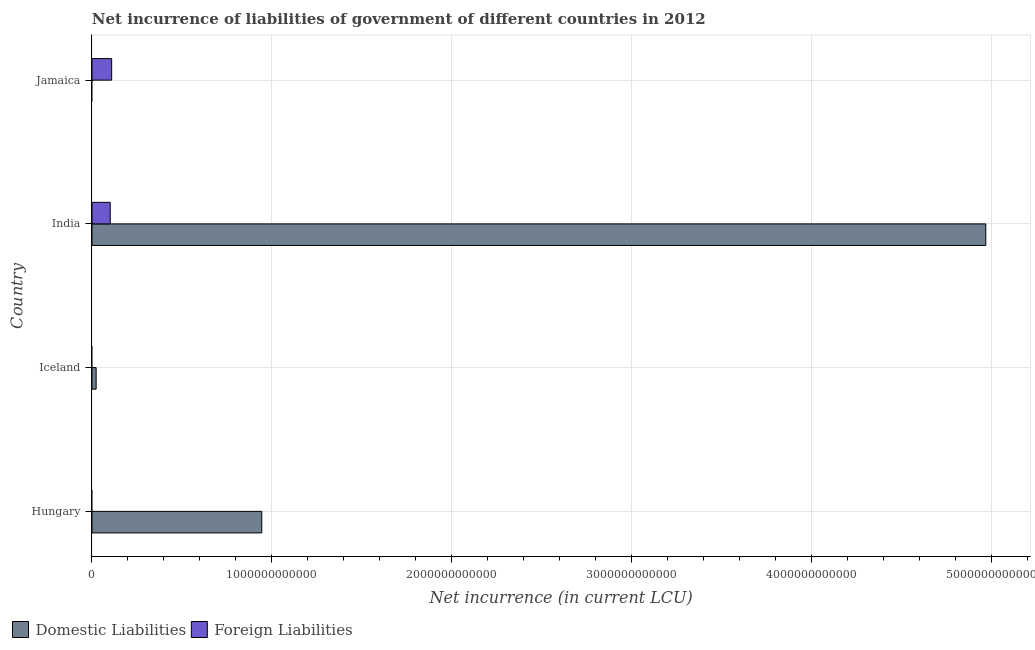Are the number of bars per tick equal to the number of legend labels?
Provide a succinct answer. No. Are the number of bars on each tick of the Y-axis equal?
Offer a terse response. No. How many bars are there on the 3rd tick from the bottom?
Offer a terse response. 2. In how many cases, is the number of bars for a given country not equal to the number of legend labels?
Provide a short and direct response. 3. What is the net incurrence of domestic liabilities in India?
Your response must be concise. 4.97e+12. Across all countries, what is the maximum net incurrence of domestic liabilities?
Offer a terse response. 4.97e+12. Across all countries, what is the minimum net incurrence of domestic liabilities?
Your response must be concise. 0. In which country was the net incurrence of domestic liabilities maximum?
Keep it short and to the point. India. What is the total net incurrence of foreign liabilities in the graph?
Ensure brevity in your answer.  2.11e+11. What is the difference between the net incurrence of domestic liabilities in Hungary and that in India?
Provide a succinct answer. -4.02e+12. What is the difference between the net incurrence of foreign liabilities in Hungary and the net incurrence of domestic liabilities in India?
Keep it short and to the point. -4.97e+12. What is the average net incurrence of foreign liabilities per country?
Ensure brevity in your answer.  5.27e+1. What is the difference between the net incurrence of domestic liabilities and net incurrence of foreign liabilities in India?
Offer a terse response. 4.87e+12. In how many countries, is the net incurrence of foreign liabilities greater than 4000000000000 LCU?
Offer a very short reply. 0. What is the ratio of the net incurrence of domestic liabilities in Hungary to that in Iceland?
Your response must be concise. 40.77. What is the difference between the highest and the second highest net incurrence of domestic liabilities?
Give a very brief answer. 4.02e+12. What is the difference between the highest and the lowest net incurrence of domestic liabilities?
Offer a very short reply. 4.97e+12. In how many countries, is the net incurrence of foreign liabilities greater than the average net incurrence of foreign liabilities taken over all countries?
Provide a succinct answer. 2. How many bars are there?
Your response must be concise. 5. Are all the bars in the graph horizontal?
Make the answer very short. Yes. What is the difference between two consecutive major ticks on the X-axis?
Your response must be concise. 1.00e+12. Are the values on the major ticks of X-axis written in scientific E-notation?
Your response must be concise. No. What is the title of the graph?
Provide a succinct answer. Net incurrence of liabilities of government of different countries in 2012. What is the label or title of the X-axis?
Your answer should be compact. Net incurrence (in current LCU). What is the label or title of the Y-axis?
Your answer should be compact. Country. What is the Net incurrence (in current LCU) in Domestic Liabilities in Hungary?
Provide a short and direct response. 9.44e+11. What is the Net incurrence (in current LCU) of Domestic Liabilities in Iceland?
Give a very brief answer. 2.31e+1. What is the Net incurrence (in current LCU) of Foreign Liabilities in Iceland?
Your response must be concise. 0. What is the Net incurrence (in current LCU) in Domestic Liabilities in India?
Your answer should be very brief. 4.97e+12. What is the Net incurrence (in current LCU) in Foreign Liabilities in India?
Provide a succinct answer. 1.01e+11. What is the Net incurrence (in current LCU) of Domestic Liabilities in Jamaica?
Give a very brief answer. 0. What is the Net incurrence (in current LCU) of Foreign Liabilities in Jamaica?
Your response must be concise. 1.09e+11. Across all countries, what is the maximum Net incurrence (in current LCU) of Domestic Liabilities?
Keep it short and to the point. 4.97e+12. Across all countries, what is the maximum Net incurrence (in current LCU) of Foreign Liabilities?
Keep it short and to the point. 1.09e+11. Across all countries, what is the minimum Net incurrence (in current LCU) of Domestic Liabilities?
Your answer should be very brief. 0. What is the total Net incurrence (in current LCU) in Domestic Liabilities in the graph?
Make the answer very short. 5.94e+12. What is the total Net incurrence (in current LCU) in Foreign Liabilities in the graph?
Provide a short and direct response. 2.11e+11. What is the difference between the Net incurrence (in current LCU) in Domestic Liabilities in Hungary and that in Iceland?
Make the answer very short. 9.21e+11. What is the difference between the Net incurrence (in current LCU) in Domestic Liabilities in Hungary and that in India?
Offer a terse response. -4.02e+12. What is the difference between the Net incurrence (in current LCU) of Domestic Liabilities in Iceland and that in India?
Give a very brief answer. -4.95e+12. What is the difference between the Net incurrence (in current LCU) in Foreign Liabilities in India and that in Jamaica?
Keep it short and to the point. -7.86e+09. What is the difference between the Net incurrence (in current LCU) of Domestic Liabilities in Hungary and the Net incurrence (in current LCU) of Foreign Liabilities in India?
Your answer should be compact. 8.42e+11. What is the difference between the Net incurrence (in current LCU) of Domestic Liabilities in Hungary and the Net incurrence (in current LCU) of Foreign Liabilities in Jamaica?
Your response must be concise. 8.34e+11. What is the difference between the Net incurrence (in current LCU) in Domestic Liabilities in Iceland and the Net incurrence (in current LCU) in Foreign Liabilities in India?
Ensure brevity in your answer.  -7.83e+1. What is the difference between the Net incurrence (in current LCU) in Domestic Liabilities in Iceland and the Net incurrence (in current LCU) in Foreign Liabilities in Jamaica?
Offer a terse response. -8.62e+1. What is the difference between the Net incurrence (in current LCU) of Domestic Liabilities in India and the Net incurrence (in current LCU) of Foreign Liabilities in Jamaica?
Your answer should be compact. 4.86e+12. What is the average Net incurrence (in current LCU) in Domestic Liabilities per country?
Provide a short and direct response. 1.48e+12. What is the average Net incurrence (in current LCU) in Foreign Liabilities per country?
Your answer should be compact. 5.27e+1. What is the difference between the Net incurrence (in current LCU) of Domestic Liabilities and Net incurrence (in current LCU) of Foreign Liabilities in India?
Ensure brevity in your answer.  4.87e+12. What is the ratio of the Net incurrence (in current LCU) of Domestic Liabilities in Hungary to that in Iceland?
Offer a very short reply. 40.77. What is the ratio of the Net incurrence (in current LCU) of Domestic Liabilities in Hungary to that in India?
Provide a short and direct response. 0.19. What is the ratio of the Net incurrence (in current LCU) in Domestic Liabilities in Iceland to that in India?
Your answer should be compact. 0. What is the ratio of the Net incurrence (in current LCU) of Foreign Liabilities in India to that in Jamaica?
Offer a terse response. 0.93. What is the difference between the highest and the second highest Net incurrence (in current LCU) of Domestic Liabilities?
Give a very brief answer. 4.02e+12. What is the difference between the highest and the lowest Net incurrence (in current LCU) in Domestic Liabilities?
Provide a short and direct response. 4.97e+12. What is the difference between the highest and the lowest Net incurrence (in current LCU) in Foreign Liabilities?
Your response must be concise. 1.09e+11. 